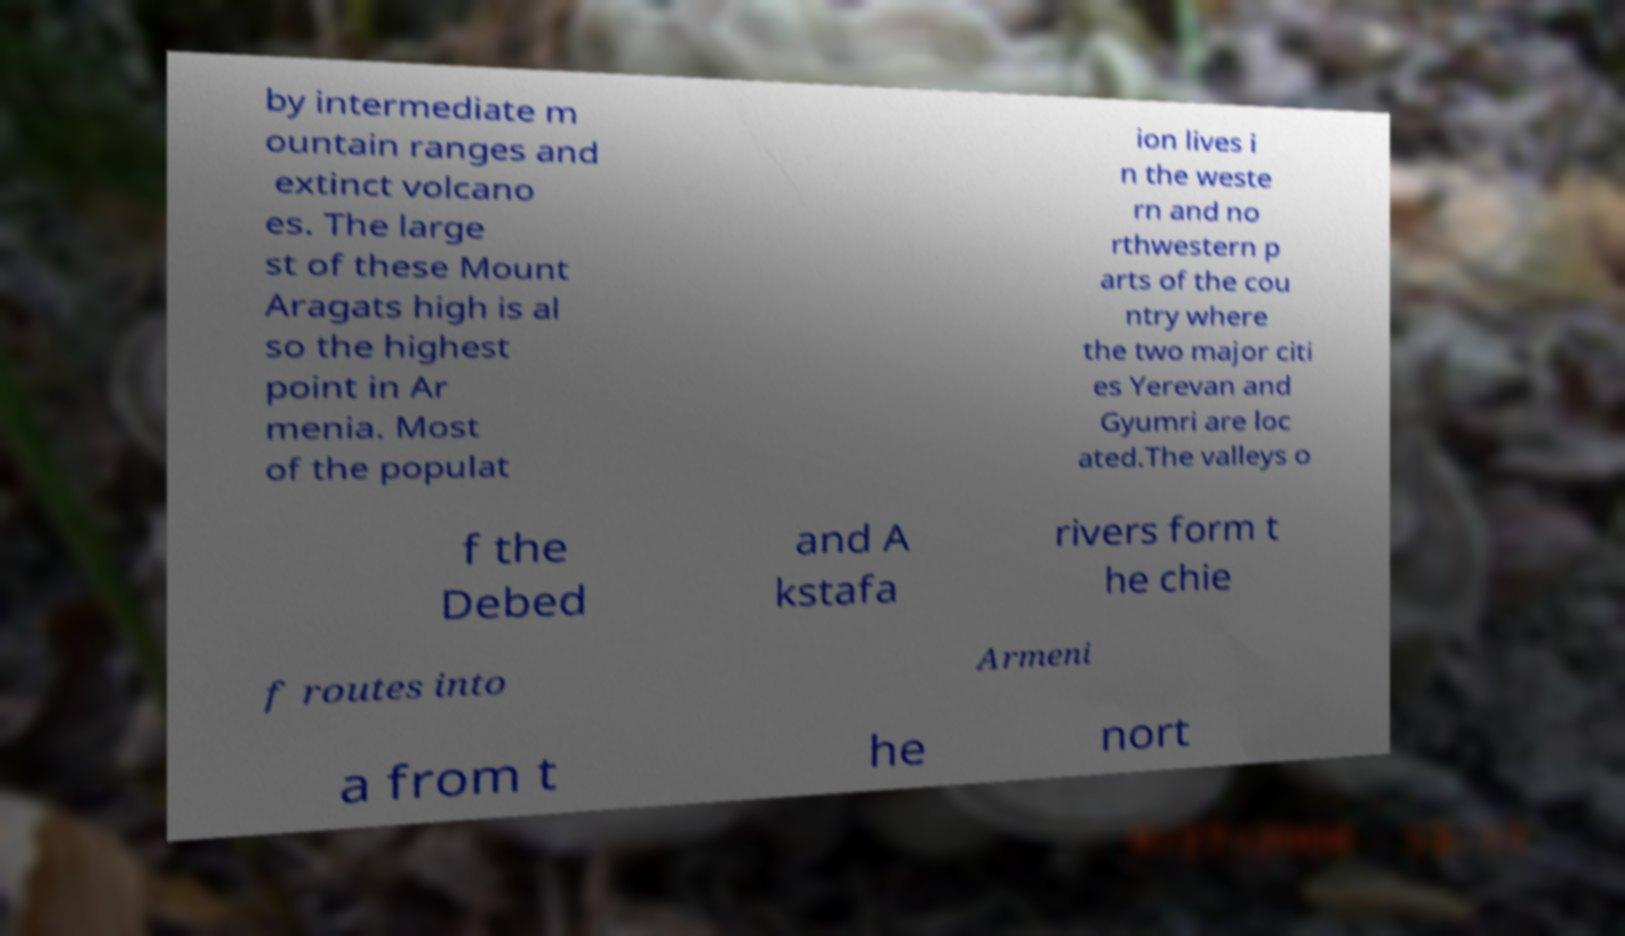What messages or text are displayed in this image? I need them in a readable, typed format. by intermediate m ountain ranges and extinct volcano es. The large st of these Mount Aragats high is al so the highest point in Ar menia. Most of the populat ion lives i n the weste rn and no rthwestern p arts of the cou ntry where the two major citi es Yerevan and Gyumri are loc ated.The valleys o f the Debed and A kstafa rivers form t he chie f routes into Armeni a from t he nort 